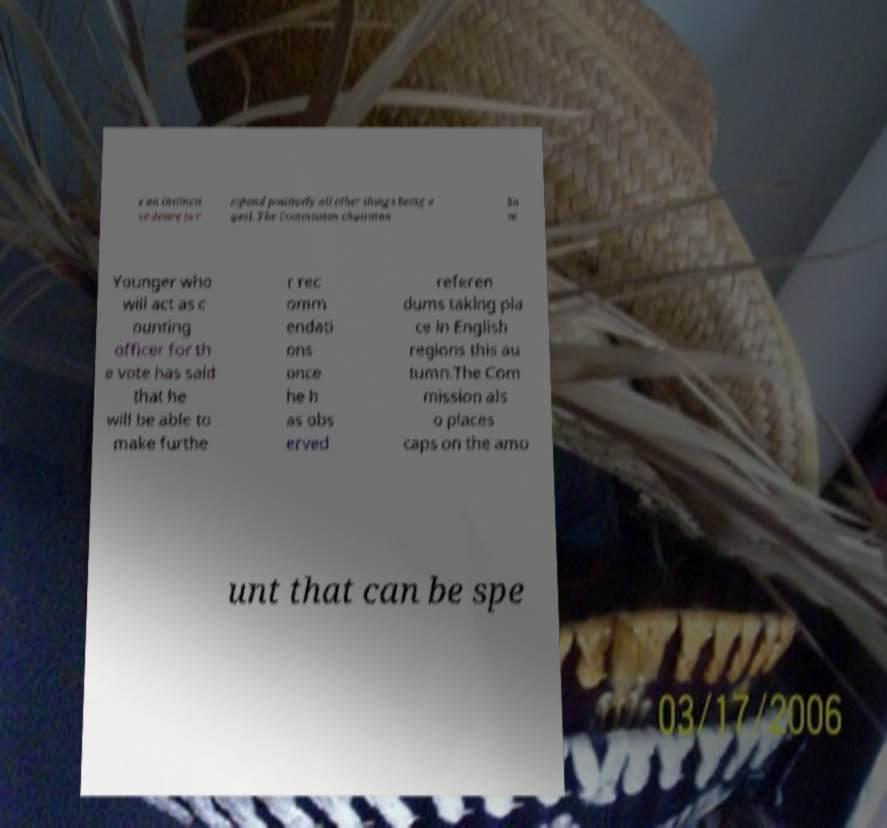I need the written content from this picture converted into text. Can you do that? e an instincti ve desire to r espond positively all other things being e qual. The Commission chairman Sa m Younger who will act as c ounting officer for th e vote has said that he will be able to make furthe r rec omm endati ons once he h as obs erved referen dums taking pla ce in English regions this au tumn.The Com mission als o places caps on the amo unt that can be spe 